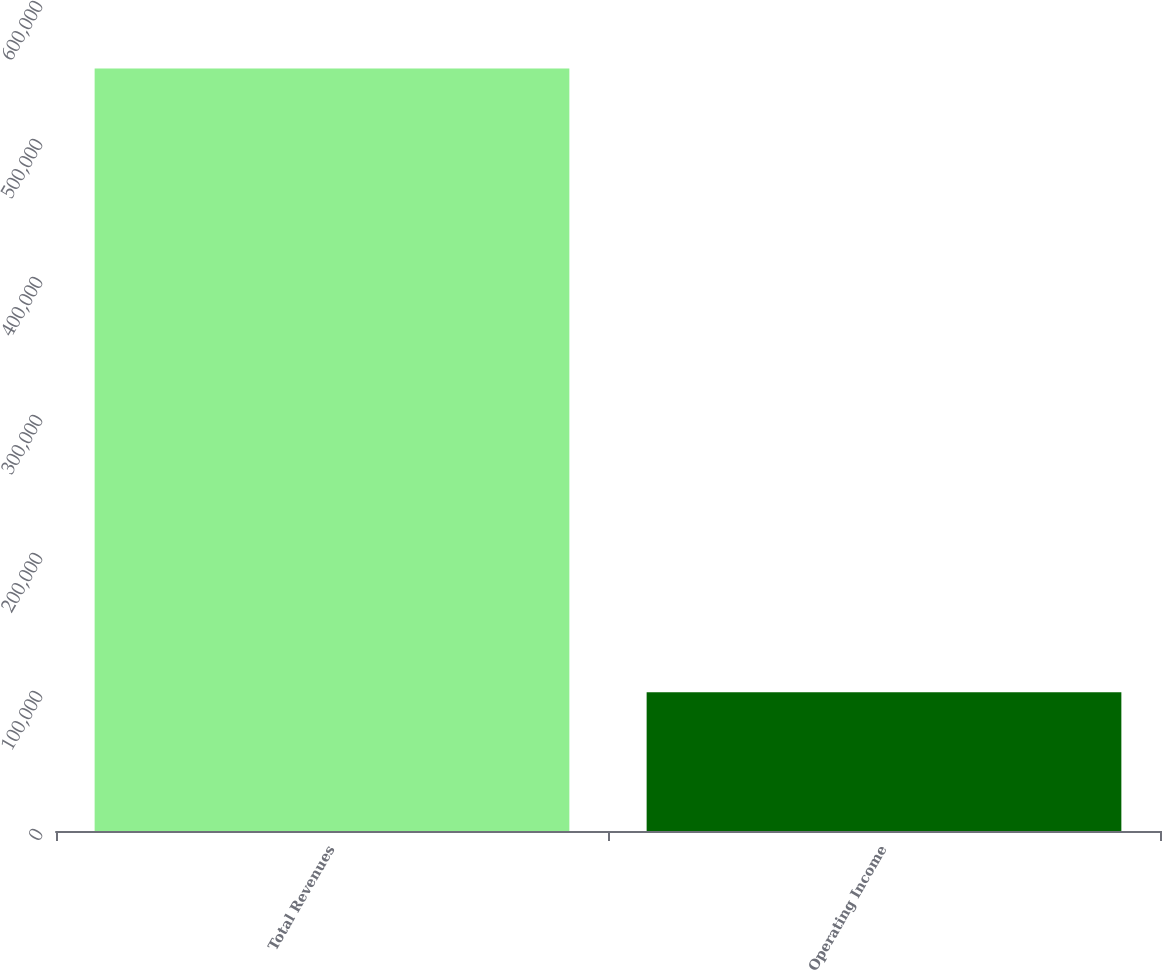<chart> <loc_0><loc_0><loc_500><loc_500><bar_chart><fcel>Total Revenues<fcel>Operating Income<nl><fcel>552501<fcel>100469<nl></chart> 